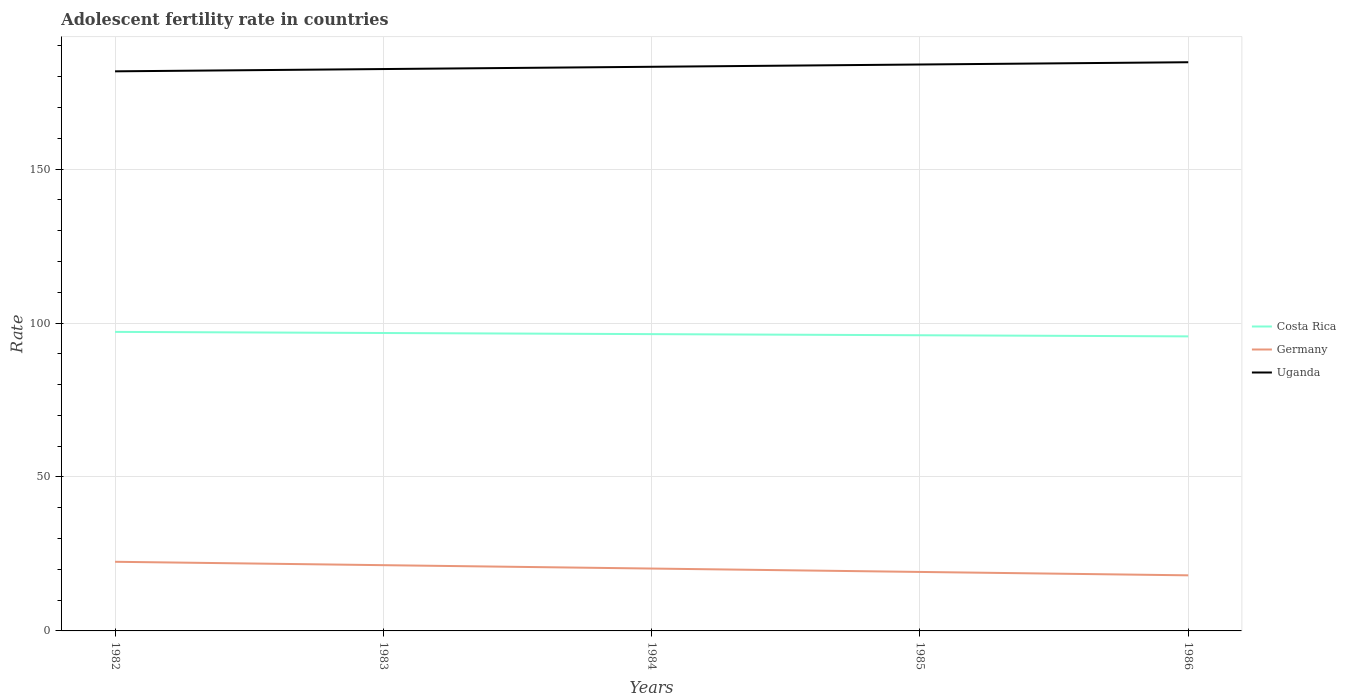How many different coloured lines are there?
Make the answer very short. 3. Does the line corresponding to Costa Rica intersect with the line corresponding to Germany?
Offer a very short reply. No. Across all years, what is the maximum adolescent fertility rate in Costa Rica?
Make the answer very short. 95.67. What is the total adolescent fertility rate in Costa Rica in the graph?
Make the answer very short. 0.37. What is the difference between the highest and the second highest adolescent fertility rate in Uganda?
Provide a succinct answer. 2.95. What is the difference between the highest and the lowest adolescent fertility rate in Germany?
Provide a succinct answer. 2. Is the adolescent fertility rate in Germany strictly greater than the adolescent fertility rate in Costa Rica over the years?
Your answer should be very brief. Yes. How many lines are there?
Provide a succinct answer. 3. How many years are there in the graph?
Ensure brevity in your answer.  5. Does the graph contain any zero values?
Make the answer very short. No. Does the graph contain grids?
Provide a short and direct response. Yes. Where does the legend appear in the graph?
Keep it short and to the point. Center right. How are the legend labels stacked?
Keep it short and to the point. Vertical. What is the title of the graph?
Offer a very short reply. Adolescent fertility rate in countries. Does "Malaysia" appear as one of the legend labels in the graph?
Offer a terse response. No. What is the label or title of the X-axis?
Offer a terse response. Years. What is the label or title of the Y-axis?
Your answer should be compact. Rate. What is the Rate of Costa Rica in 1982?
Provide a succinct answer. 97.13. What is the Rate in Germany in 1982?
Your answer should be very brief. 22.46. What is the Rate in Uganda in 1982?
Your answer should be compact. 181.76. What is the Rate in Costa Rica in 1983?
Keep it short and to the point. 96.76. What is the Rate in Germany in 1983?
Make the answer very short. 21.36. What is the Rate of Uganda in 1983?
Provide a short and direct response. 182.5. What is the Rate of Costa Rica in 1984?
Provide a succinct answer. 96.4. What is the Rate in Germany in 1984?
Your answer should be compact. 20.26. What is the Rate of Uganda in 1984?
Provide a succinct answer. 183.24. What is the Rate of Costa Rica in 1985?
Keep it short and to the point. 96.03. What is the Rate of Germany in 1985?
Offer a terse response. 19.16. What is the Rate of Uganda in 1985?
Keep it short and to the point. 183.98. What is the Rate of Costa Rica in 1986?
Keep it short and to the point. 95.67. What is the Rate of Germany in 1986?
Make the answer very short. 18.06. What is the Rate of Uganda in 1986?
Ensure brevity in your answer.  184.71. Across all years, what is the maximum Rate in Costa Rica?
Offer a terse response. 97.13. Across all years, what is the maximum Rate of Germany?
Make the answer very short. 22.46. Across all years, what is the maximum Rate of Uganda?
Provide a short and direct response. 184.71. Across all years, what is the minimum Rate in Costa Rica?
Make the answer very short. 95.67. Across all years, what is the minimum Rate in Germany?
Your response must be concise. 18.06. Across all years, what is the minimum Rate in Uganda?
Make the answer very short. 181.76. What is the total Rate in Costa Rica in the graph?
Your answer should be compact. 482. What is the total Rate of Germany in the graph?
Offer a very short reply. 101.29. What is the total Rate of Uganda in the graph?
Make the answer very short. 916.18. What is the difference between the Rate of Costa Rica in 1982 and that in 1983?
Make the answer very short. 0.36. What is the difference between the Rate in Germany in 1982 and that in 1983?
Provide a succinct answer. 1.1. What is the difference between the Rate in Uganda in 1982 and that in 1983?
Your response must be concise. -0.74. What is the difference between the Rate in Costa Rica in 1982 and that in 1984?
Provide a succinct answer. 0.73. What is the difference between the Rate of Germany in 1982 and that in 1984?
Your answer should be compact. 2.2. What is the difference between the Rate of Uganda in 1982 and that in 1984?
Keep it short and to the point. -1.48. What is the difference between the Rate of Costa Rica in 1982 and that in 1985?
Provide a succinct answer. 1.09. What is the difference between the Rate in Germany in 1982 and that in 1985?
Keep it short and to the point. 3.3. What is the difference between the Rate in Uganda in 1982 and that in 1985?
Make the answer very short. -2.22. What is the difference between the Rate of Costa Rica in 1982 and that in 1986?
Make the answer very short. 1.46. What is the difference between the Rate of Germany in 1982 and that in 1986?
Offer a terse response. 4.4. What is the difference between the Rate in Uganda in 1982 and that in 1986?
Give a very brief answer. -2.95. What is the difference between the Rate in Costa Rica in 1983 and that in 1984?
Give a very brief answer. 0.36. What is the difference between the Rate of Germany in 1983 and that in 1984?
Keep it short and to the point. 1.1. What is the difference between the Rate in Uganda in 1983 and that in 1984?
Provide a succinct answer. -0.74. What is the difference between the Rate of Costa Rica in 1983 and that in 1985?
Give a very brief answer. 0.73. What is the difference between the Rate in Germany in 1983 and that in 1985?
Give a very brief answer. 2.2. What is the difference between the Rate of Uganda in 1983 and that in 1985?
Your answer should be compact. -1.48. What is the difference between the Rate of Costa Rica in 1983 and that in 1986?
Give a very brief answer. 1.09. What is the difference between the Rate of Germany in 1983 and that in 1986?
Give a very brief answer. 3.3. What is the difference between the Rate in Uganda in 1983 and that in 1986?
Give a very brief answer. -2.22. What is the difference between the Rate of Costa Rica in 1984 and that in 1985?
Keep it short and to the point. 0.36. What is the difference between the Rate of Germany in 1984 and that in 1985?
Offer a very short reply. 1.1. What is the difference between the Rate of Uganda in 1984 and that in 1985?
Provide a succinct answer. -0.74. What is the difference between the Rate of Costa Rica in 1984 and that in 1986?
Your response must be concise. 0.73. What is the difference between the Rate of Germany in 1984 and that in 1986?
Offer a very short reply. 2.2. What is the difference between the Rate of Uganda in 1984 and that in 1986?
Ensure brevity in your answer.  -1.48. What is the difference between the Rate in Costa Rica in 1985 and that in 1986?
Provide a succinct answer. 0.36. What is the difference between the Rate of Germany in 1985 and that in 1986?
Offer a very short reply. 1.1. What is the difference between the Rate in Uganda in 1985 and that in 1986?
Your answer should be compact. -0.74. What is the difference between the Rate in Costa Rica in 1982 and the Rate in Germany in 1983?
Offer a terse response. 75.77. What is the difference between the Rate in Costa Rica in 1982 and the Rate in Uganda in 1983?
Give a very brief answer. -85.37. What is the difference between the Rate in Germany in 1982 and the Rate in Uganda in 1983?
Offer a very short reply. -160.04. What is the difference between the Rate of Costa Rica in 1982 and the Rate of Germany in 1984?
Make the answer very short. 76.87. What is the difference between the Rate in Costa Rica in 1982 and the Rate in Uganda in 1984?
Provide a succinct answer. -86.11. What is the difference between the Rate in Germany in 1982 and the Rate in Uganda in 1984?
Your answer should be very brief. -160.78. What is the difference between the Rate in Costa Rica in 1982 and the Rate in Germany in 1985?
Offer a terse response. 77.97. What is the difference between the Rate of Costa Rica in 1982 and the Rate of Uganda in 1985?
Your answer should be very brief. -86.85. What is the difference between the Rate of Germany in 1982 and the Rate of Uganda in 1985?
Your response must be concise. -161.52. What is the difference between the Rate of Costa Rica in 1982 and the Rate of Germany in 1986?
Keep it short and to the point. 79.07. What is the difference between the Rate of Costa Rica in 1982 and the Rate of Uganda in 1986?
Keep it short and to the point. -87.58. What is the difference between the Rate in Germany in 1982 and the Rate in Uganda in 1986?
Offer a very short reply. -162.25. What is the difference between the Rate of Costa Rica in 1983 and the Rate of Germany in 1984?
Your answer should be compact. 76.51. What is the difference between the Rate of Costa Rica in 1983 and the Rate of Uganda in 1984?
Provide a short and direct response. -86.47. What is the difference between the Rate in Germany in 1983 and the Rate in Uganda in 1984?
Offer a terse response. -161.88. What is the difference between the Rate in Costa Rica in 1983 and the Rate in Germany in 1985?
Offer a very short reply. 77.61. What is the difference between the Rate of Costa Rica in 1983 and the Rate of Uganda in 1985?
Your answer should be very brief. -87.21. What is the difference between the Rate of Germany in 1983 and the Rate of Uganda in 1985?
Offer a terse response. -162.62. What is the difference between the Rate in Costa Rica in 1983 and the Rate in Germany in 1986?
Your answer should be very brief. 78.71. What is the difference between the Rate of Costa Rica in 1983 and the Rate of Uganda in 1986?
Your answer should be very brief. -87.95. What is the difference between the Rate of Germany in 1983 and the Rate of Uganda in 1986?
Keep it short and to the point. -163.36. What is the difference between the Rate of Costa Rica in 1984 and the Rate of Germany in 1985?
Offer a very short reply. 77.24. What is the difference between the Rate in Costa Rica in 1984 and the Rate in Uganda in 1985?
Offer a terse response. -87.58. What is the difference between the Rate of Germany in 1984 and the Rate of Uganda in 1985?
Offer a terse response. -163.72. What is the difference between the Rate in Costa Rica in 1984 and the Rate in Germany in 1986?
Your answer should be compact. 78.34. What is the difference between the Rate in Costa Rica in 1984 and the Rate in Uganda in 1986?
Your answer should be very brief. -88.31. What is the difference between the Rate in Germany in 1984 and the Rate in Uganda in 1986?
Make the answer very short. -164.46. What is the difference between the Rate of Costa Rica in 1985 and the Rate of Germany in 1986?
Keep it short and to the point. 77.98. What is the difference between the Rate in Costa Rica in 1985 and the Rate in Uganda in 1986?
Keep it short and to the point. -88.68. What is the difference between the Rate of Germany in 1985 and the Rate of Uganda in 1986?
Your response must be concise. -165.56. What is the average Rate in Costa Rica per year?
Your answer should be very brief. 96.4. What is the average Rate in Germany per year?
Your answer should be compact. 20.26. What is the average Rate of Uganda per year?
Offer a very short reply. 183.24. In the year 1982, what is the difference between the Rate of Costa Rica and Rate of Germany?
Your response must be concise. 74.67. In the year 1982, what is the difference between the Rate of Costa Rica and Rate of Uganda?
Keep it short and to the point. -84.63. In the year 1982, what is the difference between the Rate in Germany and Rate in Uganda?
Provide a succinct answer. -159.3. In the year 1983, what is the difference between the Rate of Costa Rica and Rate of Germany?
Your answer should be very brief. 75.41. In the year 1983, what is the difference between the Rate in Costa Rica and Rate in Uganda?
Offer a terse response. -85.73. In the year 1983, what is the difference between the Rate of Germany and Rate of Uganda?
Keep it short and to the point. -161.14. In the year 1984, what is the difference between the Rate of Costa Rica and Rate of Germany?
Provide a succinct answer. 76.14. In the year 1984, what is the difference between the Rate of Costa Rica and Rate of Uganda?
Your answer should be very brief. -86.84. In the year 1984, what is the difference between the Rate in Germany and Rate in Uganda?
Provide a short and direct response. -162.98. In the year 1985, what is the difference between the Rate in Costa Rica and Rate in Germany?
Your answer should be compact. 76.88. In the year 1985, what is the difference between the Rate of Costa Rica and Rate of Uganda?
Offer a terse response. -87.94. In the year 1985, what is the difference between the Rate of Germany and Rate of Uganda?
Ensure brevity in your answer.  -164.82. In the year 1986, what is the difference between the Rate of Costa Rica and Rate of Germany?
Offer a terse response. 77.61. In the year 1986, what is the difference between the Rate in Costa Rica and Rate in Uganda?
Keep it short and to the point. -89.04. In the year 1986, what is the difference between the Rate of Germany and Rate of Uganda?
Give a very brief answer. -166.66. What is the ratio of the Rate of Germany in 1982 to that in 1983?
Provide a succinct answer. 1.05. What is the ratio of the Rate of Uganda in 1982 to that in 1983?
Your response must be concise. 1. What is the ratio of the Rate of Costa Rica in 1982 to that in 1984?
Offer a very short reply. 1.01. What is the ratio of the Rate in Germany in 1982 to that in 1984?
Keep it short and to the point. 1.11. What is the ratio of the Rate in Uganda in 1982 to that in 1984?
Offer a terse response. 0.99. What is the ratio of the Rate in Costa Rica in 1982 to that in 1985?
Provide a succinct answer. 1.01. What is the ratio of the Rate in Germany in 1982 to that in 1985?
Provide a succinct answer. 1.17. What is the ratio of the Rate of Uganda in 1982 to that in 1985?
Your answer should be very brief. 0.99. What is the ratio of the Rate in Costa Rica in 1982 to that in 1986?
Make the answer very short. 1.02. What is the ratio of the Rate in Germany in 1982 to that in 1986?
Provide a short and direct response. 1.24. What is the ratio of the Rate in Costa Rica in 1983 to that in 1984?
Provide a succinct answer. 1. What is the ratio of the Rate in Germany in 1983 to that in 1984?
Offer a terse response. 1.05. What is the ratio of the Rate in Costa Rica in 1983 to that in 1985?
Keep it short and to the point. 1.01. What is the ratio of the Rate in Germany in 1983 to that in 1985?
Ensure brevity in your answer.  1.11. What is the ratio of the Rate of Costa Rica in 1983 to that in 1986?
Make the answer very short. 1.01. What is the ratio of the Rate in Germany in 1983 to that in 1986?
Keep it short and to the point. 1.18. What is the ratio of the Rate in Uganda in 1983 to that in 1986?
Offer a terse response. 0.99. What is the ratio of the Rate of Germany in 1984 to that in 1985?
Your answer should be compact. 1.06. What is the ratio of the Rate of Uganda in 1984 to that in 1985?
Your response must be concise. 1. What is the ratio of the Rate in Costa Rica in 1984 to that in 1986?
Offer a very short reply. 1.01. What is the ratio of the Rate of Germany in 1984 to that in 1986?
Ensure brevity in your answer.  1.12. What is the ratio of the Rate of Uganda in 1984 to that in 1986?
Make the answer very short. 0.99. What is the ratio of the Rate in Germany in 1985 to that in 1986?
Make the answer very short. 1.06. What is the ratio of the Rate of Uganda in 1985 to that in 1986?
Ensure brevity in your answer.  1. What is the difference between the highest and the second highest Rate of Costa Rica?
Ensure brevity in your answer.  0.36. What is the difference between the highest and the second highest Rate in Germany?
Give a very brief answer. 1.1. What is the difference between the highest and the second highest Rate of Uganda?
Make the answer very short. 0.74. What is the difference between the highest and the lowest Rate in Costa Rica?
Your answer should be compact. 1.46. What is the difference between the highest and the lowest Rate in Germany?
Provide a succinct answer. 4.4. What is the difference between the highest and the lowest Rate in Uganda?
Ensure brevity in your answer.  2.95. 